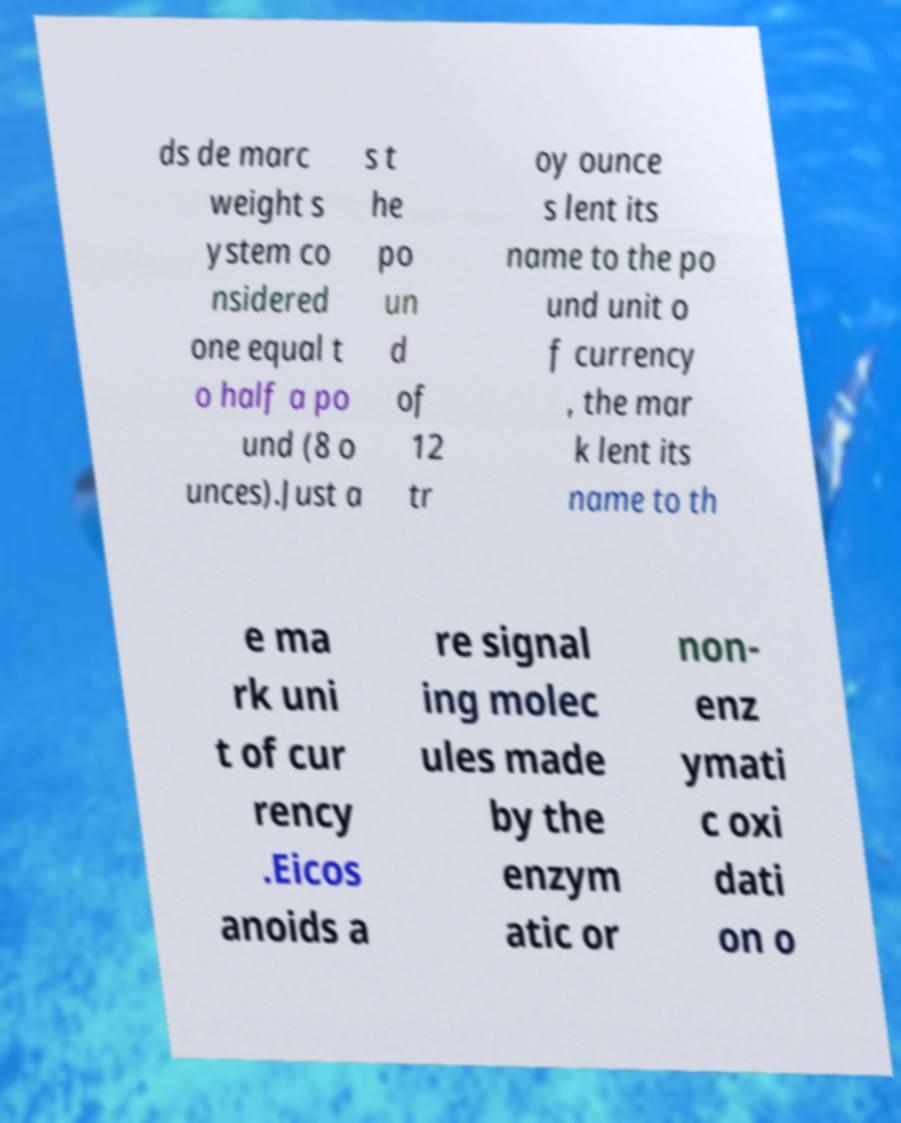What messages or text are displayed in this image? I need them in a readable, typed format. ds de marc weight s ystem co nsidered one equal t o half a po und (8 o unces).Just a s t he po un d of 12 tr oy ounce s lent its name to the po und unit o f currency , the mar k lent its name to th e ma rk uni t of cur rency .Eicos anoids a re signal ing molec ules made by the enzym atic or non- enz ymati c oxi dati on o 